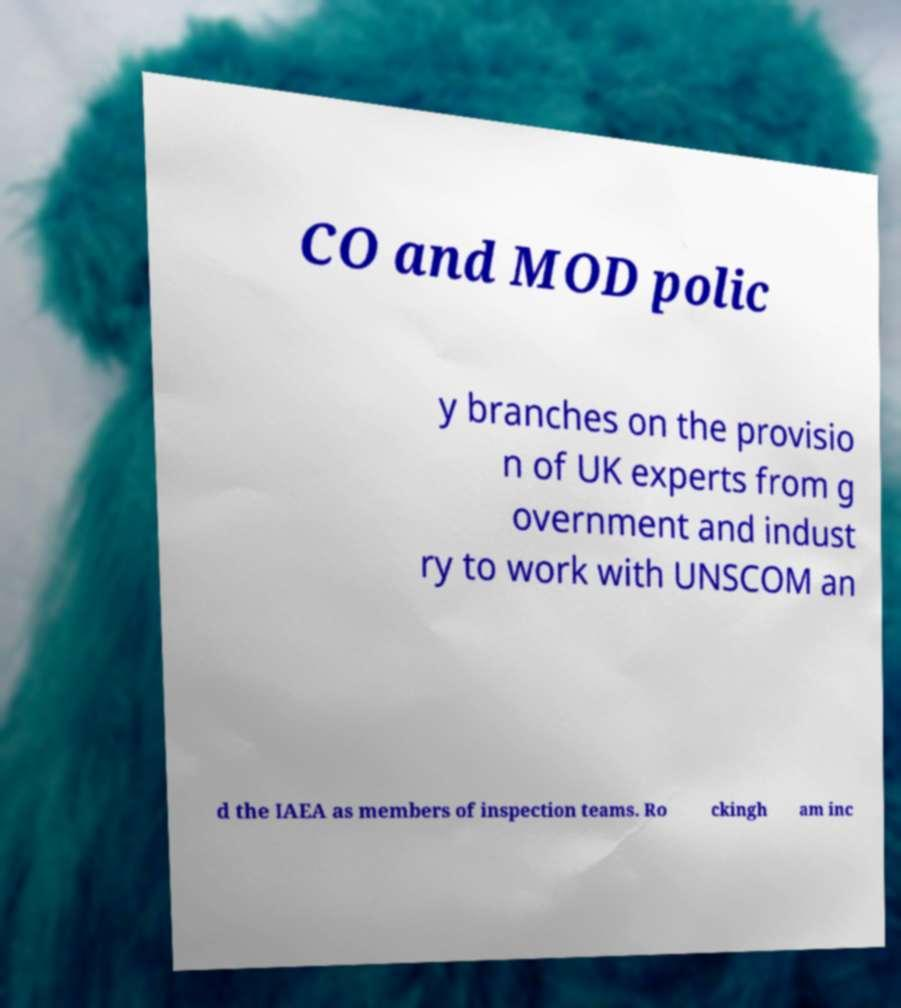Please identify and transcribe the text found in this image. CO and MOD polic y branches on the provisio n of UK experts from g overnment and indust ry to work with UNSCOM an d the IAEA as members of inspection teams. Ro ckingh am inc 